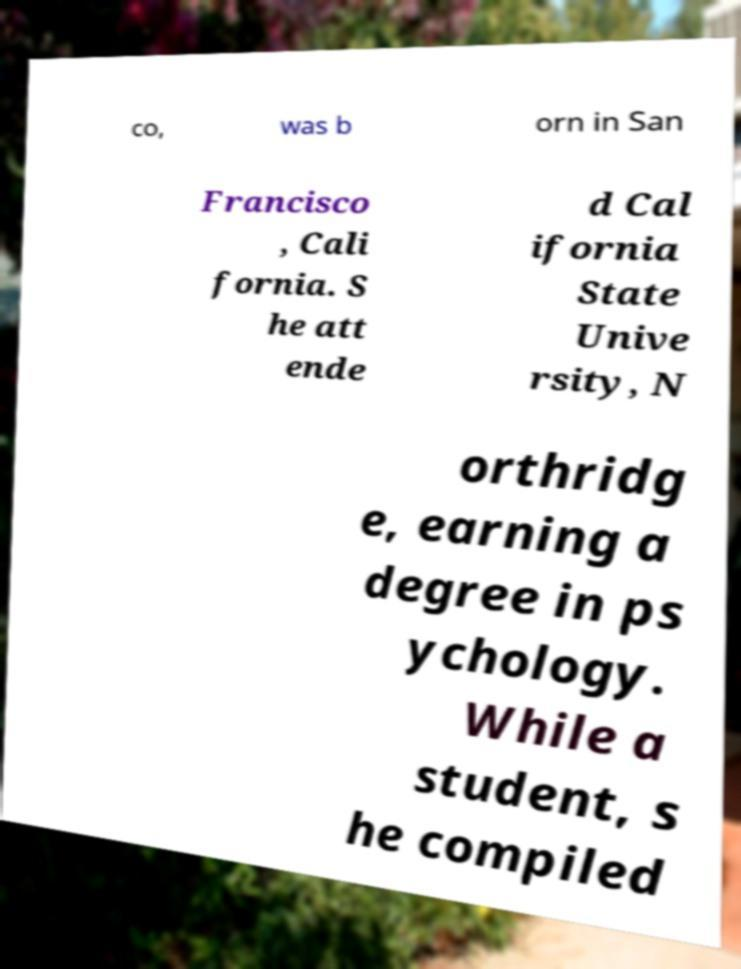Can you read and provide the text displayed in the image?This photo seems to have some interesting text. Can you extract and type it out for me? co, was b orn in San Francisco , Cali fornia. S he att ende d Cal ifornia State Unive rsity, N orthridg e, earning a degree in ps ychology. While a student, s he compiled 